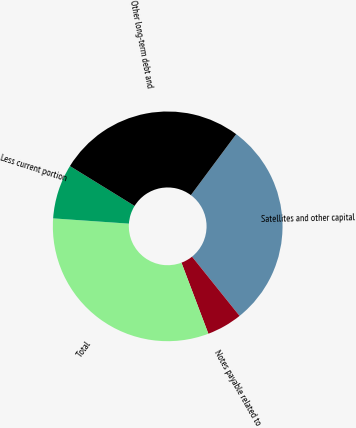<chart> <loc_0><loc_0><loc_500><loc_500><pie_chart><fcel>Satellites and other capital<fcel>Notes payable related to<fcel>Total<fcel>Less current portion<fcel>Other long-term debt and<nl><fcel>29.07%<fcel>5.0%<fcel>31.87%<fcel>7.69%<fcel>26.38%<nl></chart> 